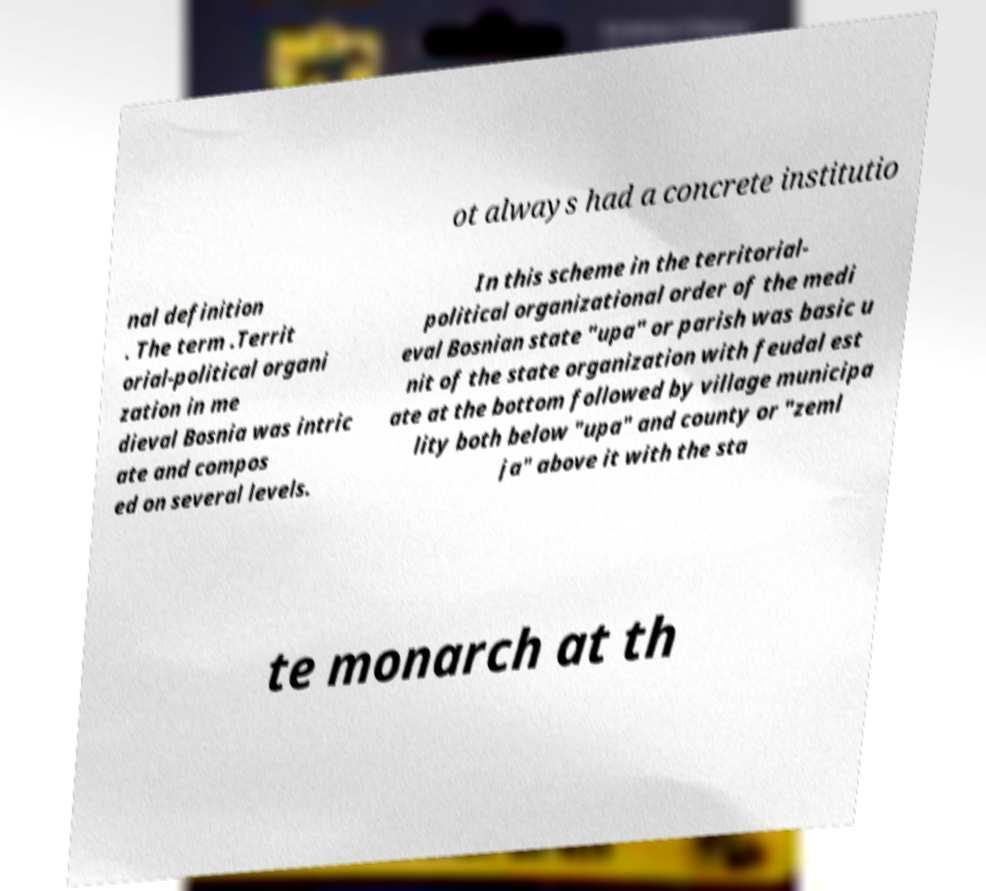I need the written content from this picture converted into text. Can you do that? ot always had a concrete institutio nal definition . The term .Territ orial-political organi zation in me dieval Bosnia was intric ate and compos ed on several levels. In this scheme in the territorial- political organizational order of the medi eval Bosnian state "upa" or parish was basic u nit of the state organization with feudal est ate at the bottom followed by village municipa lity both below "upa" and county or "zeml ja" above it with the sta te monarch at th 